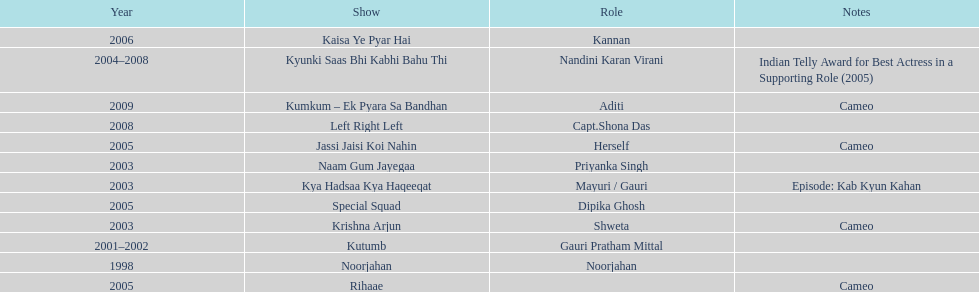In total, how many different tv series has gauri tejwani either starred or cameoed in? 11. 